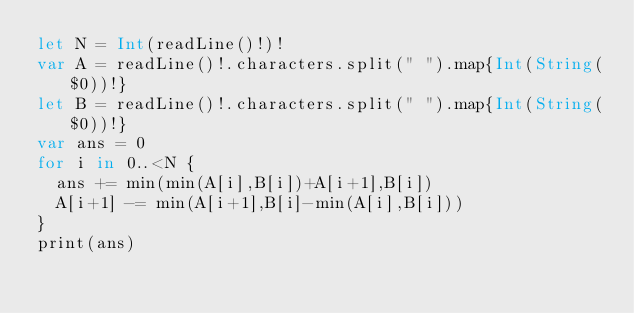<code> <loc_0><loc_0><loc_500><loc_500><_Swift_>let N = Int(readLine()!)!
var A = readLine()!.characters.split(" ").map{Int(String($0))!}
let B = readLine()!.characters.split(" ").map{Int(String($0))!}
var ans = 0
for i in 0..<N {
  ans += min(min(A[i],B[i])+A[i+1],B[i])
  A[i+1] -= min(A[i+1],B[i]-min(A[i],B[i]))
}
print(ans)</code> 